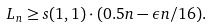<formula> <loc_0><loc_0><loc_500><loc_500>L _ { n } \geq s ( 1 , 1 ) \cdot ( 0 . 5 n - \epsilon n / 1 6 ) .</formula> 